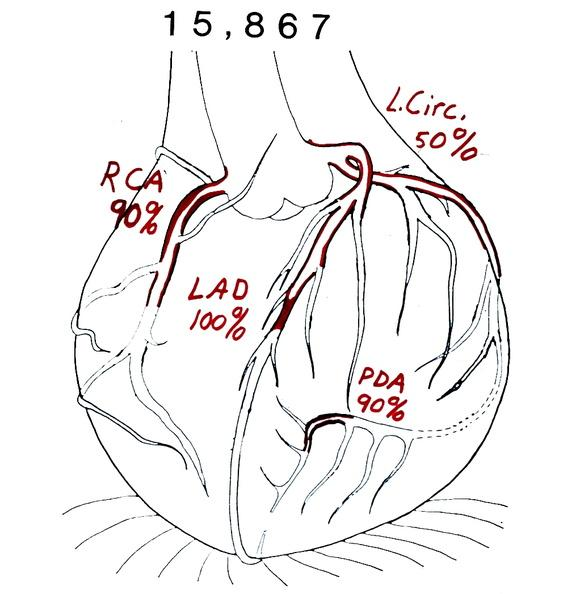does this image show coronary artery atherosclerosis diagram?
Answer the question using a single word or phrase. Yes 